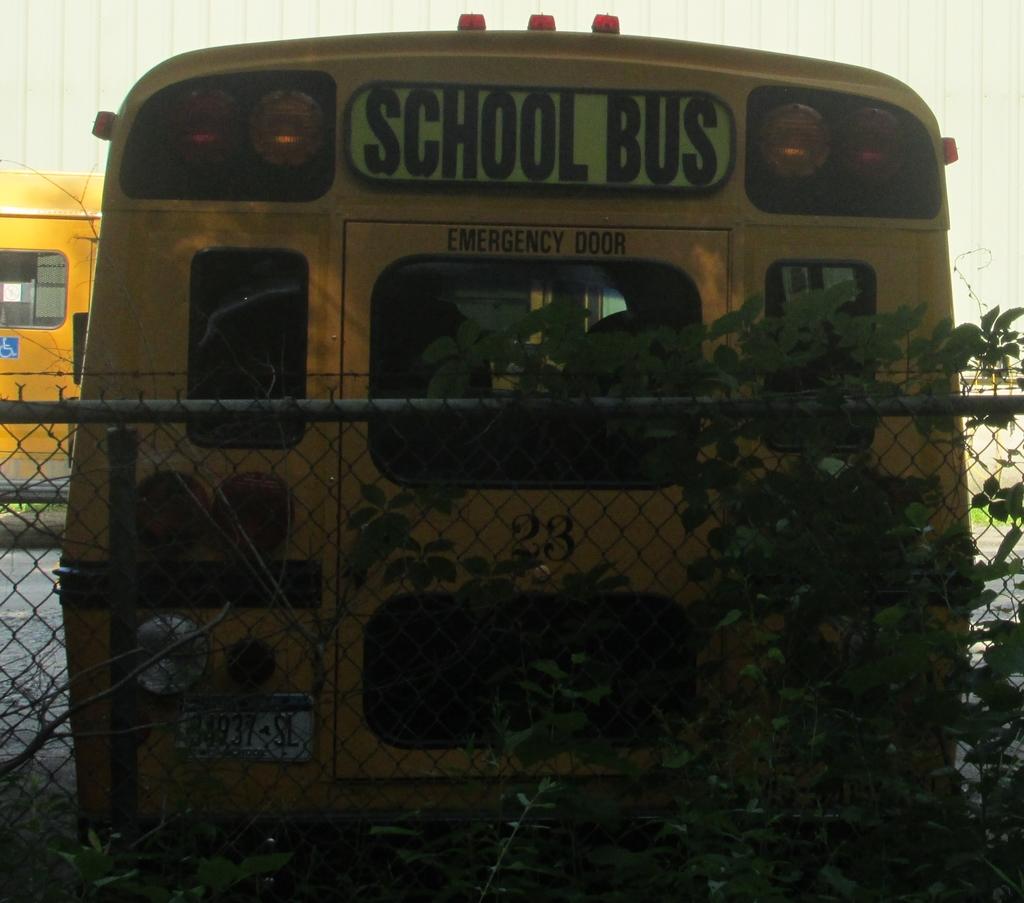What number is on the school bus?
Give a very brief answer. 23. Hat kind of bus?
Offer a very short reply. School. 